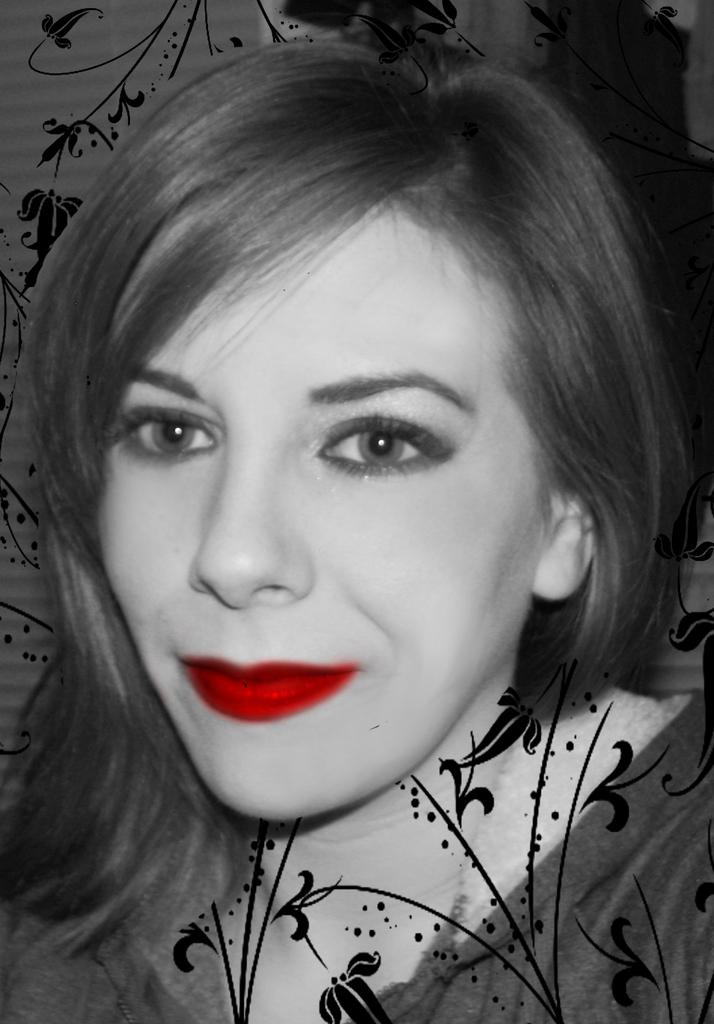Who is present in the image? There is a woman in the image. What can be seen in the background of the image? There is a painting in the background of the image. What type of amusement can be seen on the desk in the image? There is no desk present in the image, and therefore no amusement on a desk can be observed. 